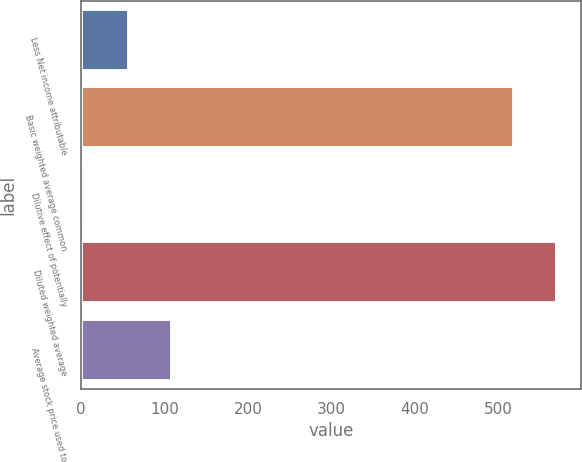<chart> <loc_0><loc_0><loc_500><loc_500><bar_chart><fcel>Less Net income attributable<fcel>Basic weighted average common<fcel>Dilutive effect of potentially<fcel>Diluted weighted average<fcel>Average stock price used to<nl><fcel>56.9<fcel>519<fcel>5<fcel>570.9<fcel>108.8<nl></chart> 